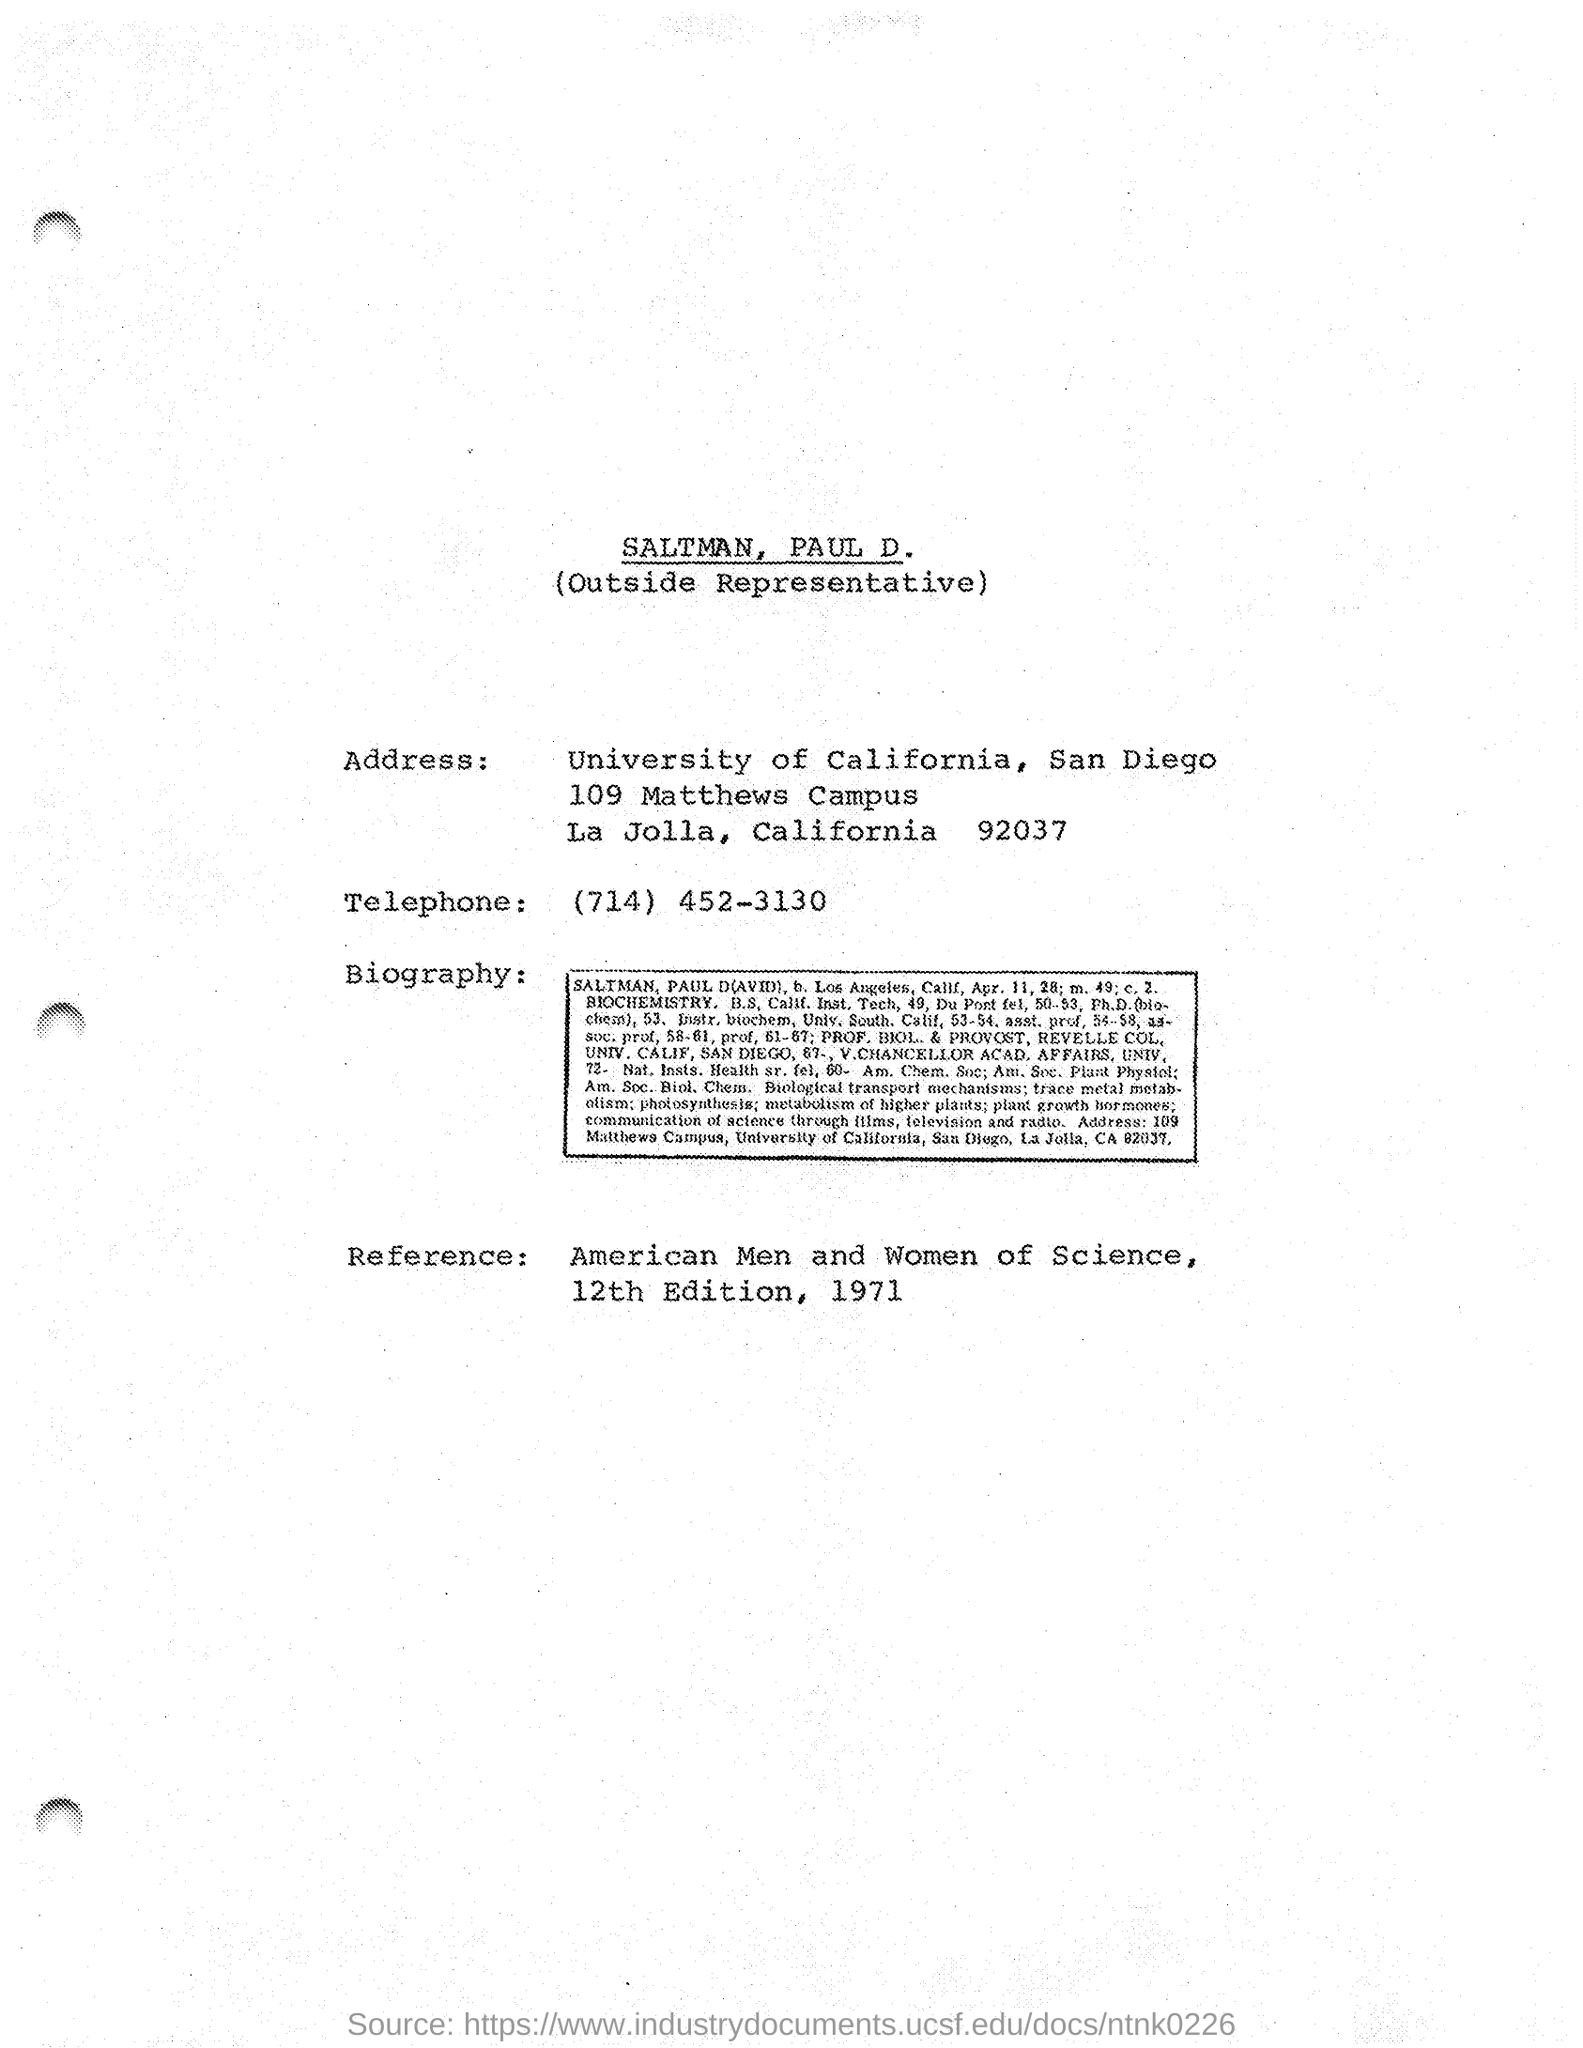Who is the Outside Representative?
Offer a terse response. SALTMAN. What is the Telephone?
Your response must be concise. (714) 452-3130. 